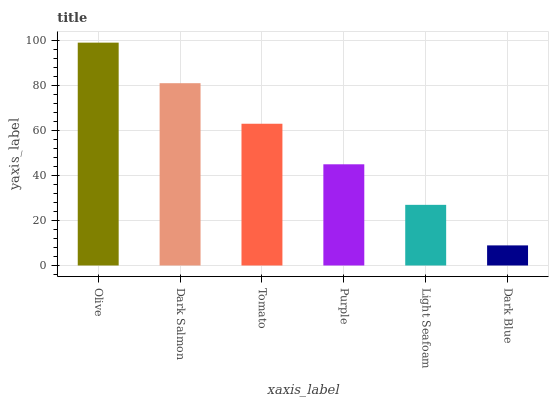Is Dark Salmon the minimum?
Answer yes or no. No. Is Dark Salmon the maximum?
Answer yes or no. No. Is Olive greater than Dark Salmon?
Answer yes or no. Yes. Is Dark Salmon less than Olive?
Answer yes or no. Yes. Is Dark Salmon greater than Olive?
Answer yes or no. No. Is Olive less than Dark Salmon?
Answer yes or no. No. Is Tomato the high median?
Answer yes or no. Yes. Is Purple the low median?
Answer yes or no. Yes. Is Dark Salmon the high median?
Answer yes or no. No. Is Olive the low median?
Answer yes or no. No. 